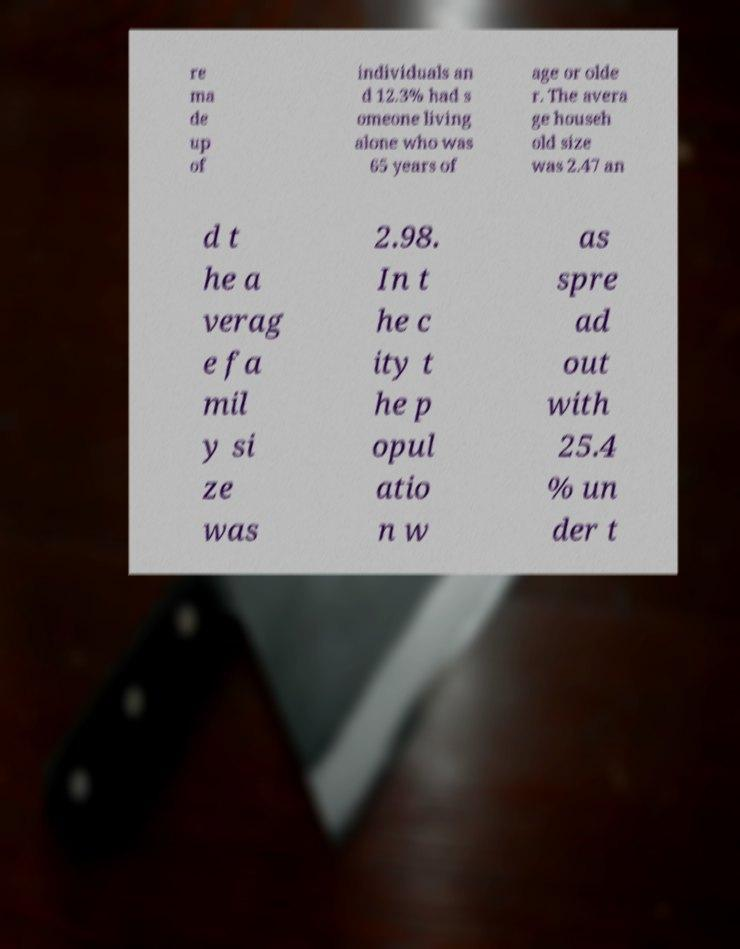For documentation purposes, I need the text within this image transcribed. Could you provide that? re ma de up of individuals an d 12.3% had s omeone living alone who was 65 years of age or olde r. The avera ge househ old size was 2.47 an d t he a verag e fa mil y si ze was 2.98. In t he c ity t he p opul atio n w as spre ad out with 25.4 % un der t 